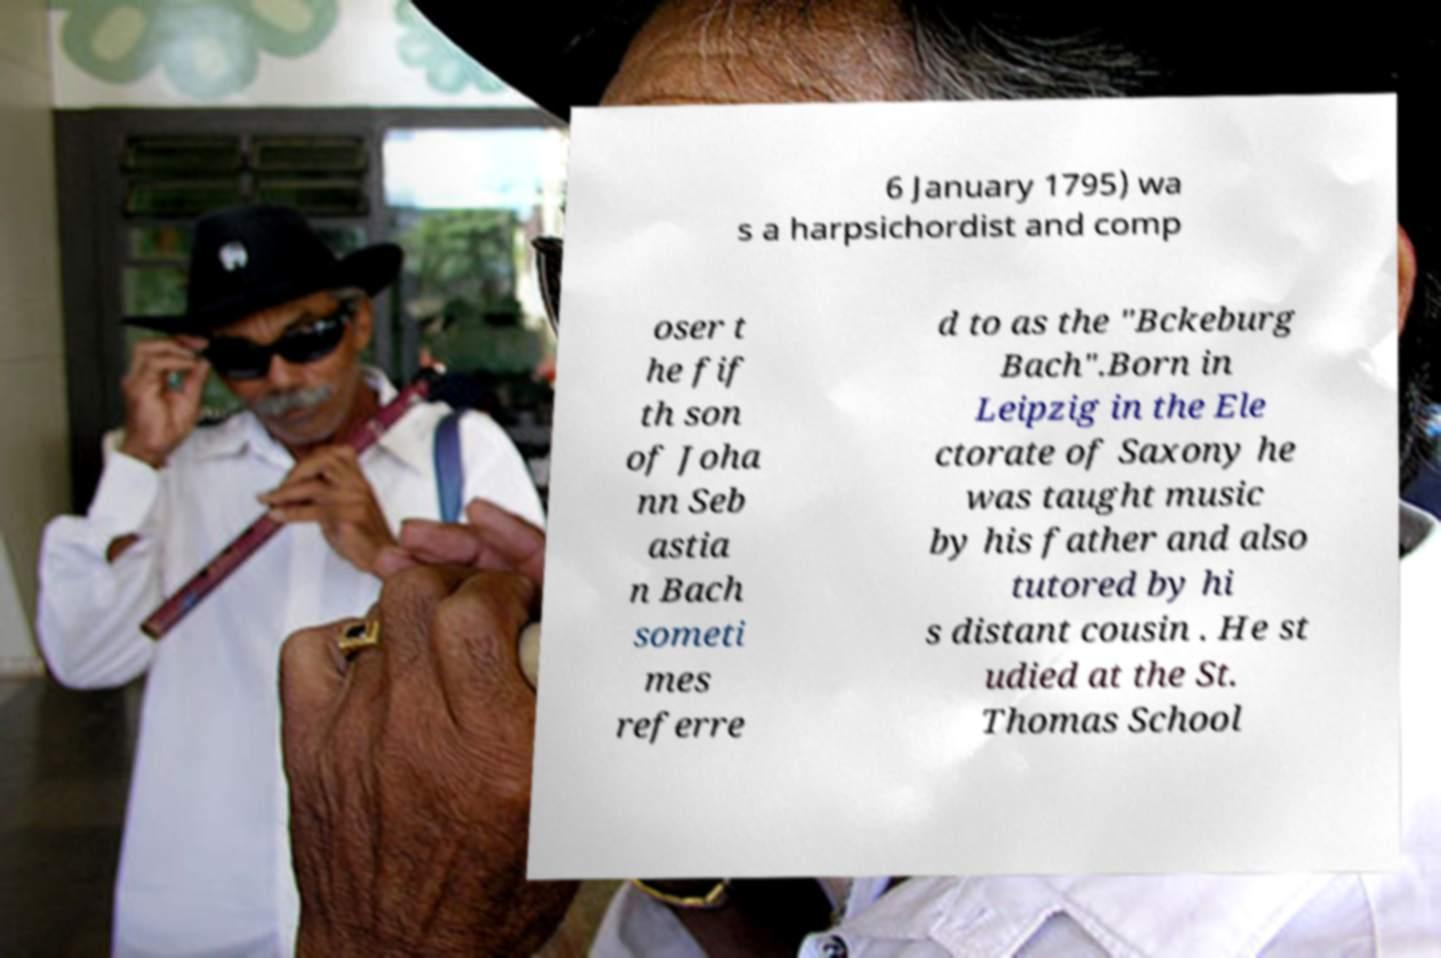For documentation purposes, I need the text within this image transcribed. Could you provide that? 6 January 1795) wa s a harpsichordist and comp oser t he fif th son of Joha nn Seb astia n Bach someti mes referre d to as the "Bckeburg Bach".Born in Leipzig in the Ele ctorate of Saxony he was taught music by his father and also tutored by hi s distant cousin . He st udied at the St. Thomas School 